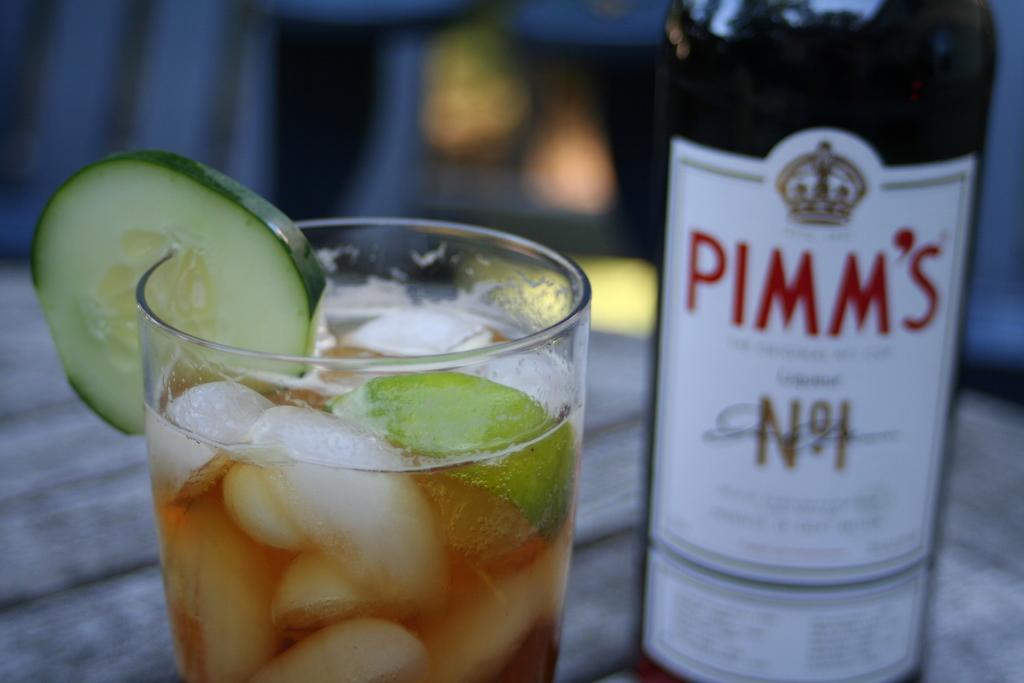What brand of alcohol is this?
Provide a short and direct response. Pimm's. Whtas in the glass?
Keep it short and to the point. Pimm's. 